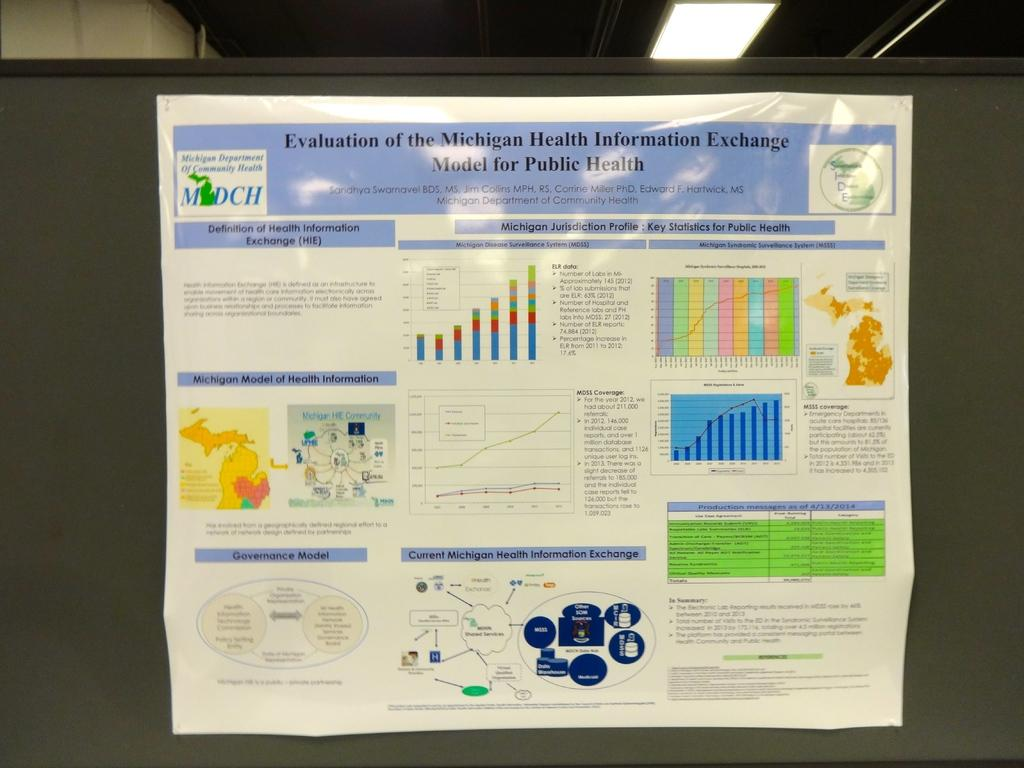<image>
Summarize the visual content of the image. A poster of the Michigan health information exchange 